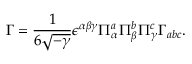Convert formula to latex. <formula><loc_0><loc_0><loc_500><loc_500>\Gamma = \frac { 1 } { 6 \sqrt { - \gamma } } \epsilon ^ { \alpha \beta \gamma } \Pi _ { \alpha } ^ { a } \Pi _ { \beta } ^ { b } \Pi _ { \gamma } ^ { c } \Gamma _ { a b c } .</formula> 